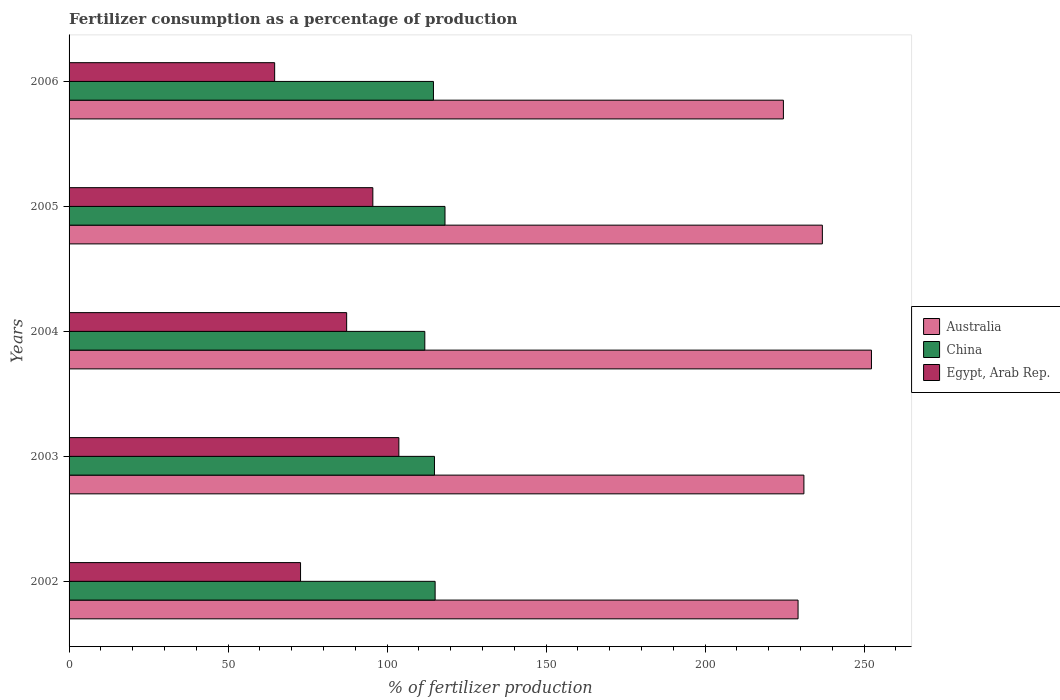Are the number of bars per tick equal to the number of legend labels?
Keep it short and to the point. Yes. What is the label of the 1st group of bars from the top?
Offer a very short reply. 2006. In how many cases, is the number of bars for a given year not equal to the number of legend labels?
Provide a succinct answer. 0. What is the percentage of fertilizers consumed in Egypt, Arab Rep. in 2003?
Make the answer very short. 103.72. Across all years, what is the maximum percentage of fertilizers consumed in Egypt, Arab Rep.?
Keep it short and to the point. 103.72. Across all years, what is the minimum percentage of fertilizers consumed in Australia?
Your answer should be compact. 224.65. In which year was the percentage of fertilizers consumed in Australia maximum?
Provide a short and direct response. 2004. In which year was the percentage of fertilizers consumed in Egypt, Arab Rep. minimum?
Give a very brief answer. 2006. What is the total percentage of fertilizers consumed in China in the graph?
Your response must be concise. 574.74. What is the difference between the percentage of fertilizers consumed in Australia in 2003 and that in 2004?
Keep it short and to the point. -21.24. What is the difference between the percentage of fertilizers consumed in China in 2004 and the percentage of fertilizers consumed in Egypt, Arab Rep. in 2002?
Offer a terse response. 39.09. What is the average percentage of fertilizers consumed in Egypt, Arab Rep. per year?
Give a very brief answer. 84.8. In the year 2004, what is the difference between the percentage of fertilizers consumed in China and percentage of fertilizers consumed in Australia?
Ensure brevity in your answer.  -140.46. In how many years, is the percentage of fertilizers consumed in Australia greater than 90 %?
Offer a very short reply. 5. What is the ratio of the percentage of fertilizers consumed in Egypt, Arab Rep. in 2003 to that in 2006?
Offer a very short reply. 1.6. Is the percentage of fertilizers consumed in Australia in 2002 less than that in 2005?
Offer a terse response. Yes. What is the difference between the highest and the second highest percentage of fertilizers consumed in Australia?
Provide a short and direct response. 15.44. What is the difference between the highest and the lowest percentage of fertilizers consumed in Egypt, Arab Rep.?
Offer a terse response. 39.07. In how many years, is the percentage of fertilizers consumed in Egypt, Arab Rep. greater than the average percentage of fertilizers consumed in Egypt, Arab Rep. taken over all years?
Your answer should be very brief. 3. Is the sum of the percentage of fertilizers consumed in Australia in 2002 and 2003 greater than the maximum percentage of fertilizers consumed in Egypt, Arab Rep. across all years?
Offer a very short reply. Yes. Is it the case that in every year, the sum of the percentage of fertilizers consumed in Australia and percentage of fertilizers consumed in China is greater than the percentage of fertilizers consumed in Egypt, Arab Rep.?
Make the answer very short. Yes. How many bars are there?
Provide a short and direct response. 15. Are all the bars in the graph horizontal?
Offer a very short reply. Yes. How many years are there in the graph?
Your answer should be very brief. 5. Does the graph contain any zero values?
Give a very brief answer. No. Does the graph contain grids?
Keep it short and to the point. No. How are the legend labels stacked?
Your answer should be compact. Vertical. What is the title of the graph?
Make the answer very short. Fertilizer consumption as a percentage of production. What is the label or title of the X-axis?
Make the answer very short. % of fertilizer production. What is the label or title of the Y-axis?
Give a very brief answer. Years. What is the % of fertilizer production of Australia in 2002?
Give a very brief answer. 229.27. What is the % of fertilizer production in China in 2002?
Keep it short and to the point. 115.12. What is the % of fertilizer production in Egypt, Arab Rep. in 2002?
Give a very brief answer. 72.8. What is the % of fertilizer production in Australia in 2003?
Your answer should be very brief. 231.1. What is the % of fertilizer production in China in 2003?
Offer a very short reply. 114.92. What is the % of fertilizer production of Egypt, Arab Rep. in 2003?
Provide a short and direct response. 103.72. What is the % of fertilizer production of Australia in 2004?
Provide a succinct answer. 252.35. What is the % of fertilizer production in China in 2004?
Provide a short and direct response. 111.88. What is the % of fertilizer production in Egypt, Arab Rep. in 2004?
Make the answer very short. 87.3. What is the % of fertilizer production of Australia in 2005?
Offer a very short reply. 236.9. What is the % of fertilizer production of China in 2005?
Keep it short and to the point. 118.23. What is the % of fertilizer production of Egypt, Arab Rep. in 2005?
Your answer should be very brief. 95.53. What is the % of fertilizer production of Australia in 2006?
Offer a very short reply. 224.65. What is the % of fertilizer production in China in 2006?
Keep it short and to the point. 114.6. What is the % of fertilizer production of Egypt, Arab Rep. in 2006?
Your response must be concise. 64.65. Across all years, what is the maximum % of fertilizer production of Australia?
Offer a terse response. 252.35. Across all years, what is the maximum % of fertilizer production of China?
Your response must be concise. 118.23. Across all years, what is the maximum % of fertilizer production of Egypt, Arab Rep.?
Ensure brevity in your answer.  103.72. Across all years, what is the minimum % of fertilizer production of Australia?
Keep it short and to the point. 224.65. Across all years, what is the minimum % of fertilizer production in China?
Provide a short and direct response. 111.88. Across all years, what is the minimum % of fertilizer production of Egypt, Arab Rep.?
Your response must be concise. 64.65. What is the total % of fertilizer production in Australia in the graph?
Your response must be concise. 1174.27. What is the total % of fertilizer production in China in the graph?
Keep it short and to the point. 574.74. What is the total % of fertilizer production of Egypt, Arab Rep. in the graph?
Make the answer very short. 424. What is the difference between the % of fertilizer production of Australia in 2002 and that in 2003?
Make the answer very short. -1.84. What is the difference between the % of fertilizer production of China in 2002 and that in 2003?
Keep it short and to the point. 0.21. What is the difference between the % of fertilizer production in Egypt, Arab Rep. in 2002 and that in 2003?
Ensure brevity in your answer.  -30.92. What is the difference between the % of fertilizer production of Australia in 2002 and that in 2004?
Your answer should be very brief. -23.08. What is the difference between the % of fertilizer production in China in 2002 and that in 2004?
Your response must be concise. 3.24. What is the difference between the % of fertilizer production in Egypt, Arab Rep. in 2002 and that in 2004?
Give a very brief answer. -14.5. What is the difference between the % of fertilizer production of Australia in 2002 and that in 2005?
Offer a very short reply. -7.64. What is the difference between the % of fertilizer production in China in 2002 and that in 2005?
Your response must be concise. -3.1. What is the difference between the % of fertilizer production in Egypt, Arab Rep. in 2002 and that in 2005?
Your answer should be compact. -22.74. What is the difference between the % of fertilizer production of Australia in 2002 and that in 2006?
Provide a succinct answer. 4.61. What is the difference between the % of fertilizer production in China in 2002 and that in 2006?
Offer a terse response. 0.53. What is the difference between the % of fertilizer production of Egypt, Arab Rep. in 2002 and that in 2006?
Your response must be concise. 8.14. What is the difference between the % of fertilizer production in Australia in 2003 and that in 2004?
Offer a terse response. -21.24. What is the difference between the % of fertilizer production of China in 2003 and that in 2004?
Offer a terse response. 3.03. What is the difference between the % of fertilizer production of Egypt, Arab Rep. in 2003 and that in 2004?
Make the answer very short. 16.42. What is the difference between the % of fertilizer production of Australia in 2003 and that in 2005?
Your answer should be very brief. -5.8. What is the difference between the % of fertilizer production in China in 2003 and that in 2005?
Make the answer very short. -3.31. What is the difference between the % of fertilizer production in Egypt, Arab Rep. in 2003 and that in 2005?
Provide a short and direct response. 8.18. What is the difference between the % of fertilizer production in Australia in 2003 and that in 2006?
Provide a succinct answer. 6.45. What is the difference between the % of fertilizer production of China in 2003 and that in 2006?
Provide a succinct answer. 0.32. What is the difference between the % of fertilizer production of Egypt, Arab Rep. in 2003 and that in 2006?
Offer a very short reply. 39.07. What is the difference between the % of fertilizer production in Australia in 2004 and that in 2005?
Offer a terse response. 15.44. What is the difference between the % of fertilizer production of China in 2004 and that in 2005?
Your answer should be very brief. -6.35. What is the difference between the % of fertilizer production of Egypt, Arab Rep. in 2004 and that in 2005?
Offer a terse response. -8.24. What is the difference between the % of fertilizer production in Australia in 2004 and that in 2006?
Your answer should be very brief. 27.69. What is the difference between the % of fertilizer production in China in 2004 and that in 2006?
Your answer should be very brief. -2.71. What is the difference between the % of fertilizer production of Egypt, Arab Rep. in 2004 and that in 2006?
Provide a short and direct response. 22.65. What is the difference between the % of fertilizer production in Australia in 2005 and that in 2006?
Give a very brief answer. 12.25. What is the difference between the % of fertilizer production of China in 2005 and that in 2006?
Give a very brief answer. 3.63. What is the difference between the % of fertilizer production in Egypt, Arab Rep. in 2005 and that in 2006?
Provide a short and direct response. 30.88. What is the difference between the % of fertilizer production in Australia in 2002 and the % of fertilizer production in China in 2003?
Keep it short and to the point. 114.35. What is the difference between the % of fertilizer production of Australia in 2002 and the % of fertilizer production of Egypt, Arab Rep. in 2003?
Your answer should be very brief. 125.55. What is the difference between the % of fertilizer production of China in 2002 and the % of fertilizer production of Egypt, Arab Rep. in 2003?
Make the answer very short. 11.4. What is the difference between the % of fertilizer production of Australia in 2002 and the % of fertilizer production of China in 2004?
Offer a terse response. 117.38. What is the difference between the % of fertilizer production of Australia in 2002 and the % of fertilizer production of Egypt, Arab Rep. in 2004?
Your answer should be very brief. 141.97. What is the difference between the % of fertilizer production in China in 2002 and the % of fertilizer production in Egypt, Arab Rep. in 2004?
Make the answer very short. 27.82. What is the difference between the % of fertilizer production of Australia in 2002 and the % of fertilizer production of China in 2005?
Provide a succinct answer. 111.04. What is the difference between the % of fertilizer production in Australia in 2002 and the % of fertilizer production in Egypt, Arab Rep. in 2005?
Give a very brief answer. 133.73. What is the difference between the % of fertilizer production of China in 2002 and the % of fertilizer production of Egypt, Arab Rep. in 2005?
Provide a short and direct response. 19.59. What is the difference between the % of fertilizer production in Australia in 2002 and the % of fertilizer production in China in 2006?
Make the answer very short. 114.67. What is the difference between the % of fertilizer production in Australia in 2002 and the % of fertilizer production in Egypt, Arab Rep. in 2006?
Your answer should be very brief. 164.61. What is the difference between the % of fertilizer production in China in 2002 and the % of fertilizer production in Egypt, Arab Rep. in 2006?
Give a very brief answer. 50.47. What is the difference between the % of fertilizer production in Australia in 2003 and the % of fertilizer production in China in 2004?
Your response must be concise. 119.22. What is the difference between the % of fertilizer production in Australia in 2003 and the % of fertilizer production in Egypt, Arab Rep. in 2004?
Make the answer very short. 143.8. What is the difference between the % of fertilizer production of China in 2003 and the % of fertilizer production of Egypt, Arab Rep. in 2004?
Keep it short and to the point. 27.62. What is the difference between the % of fertilizer production of Australia in 2003 and the % of fertilizer production of China in 2005?
Make the answer very short. 112.88. What is the difference between the % of fertilizer production of Australia in 2003 and the % of fertilizer production of Egypt, Arab Rep. in 2005?
Provide a short and direct response. 135.57. What is the difference between the % of fertilizer production in China in 2003 and the % of fertilizer production in Egypt, Arab Rep. in 2005?
Your answer should be compact. 19.38. What is the difference between the % of fertilizer production of Australia in 2003 and the % of fertilizer production of China in 2006?
Ensure brevity in your answer.  116.51. What is the difference between the % of fertilizer production of Australia in 2003 and the % of fertilizer production of Egypt, Arab Rep. in 2006?
Your response must be concise. 166.45. What is the difference between the % of fertilizer production in China in 2003 and the % of fertilizer production in Egypt, Arab Rep. in 2006?
Ensure brevity in your answer.  50.26. What is the difference between the % of fertilizer production of Australia in 2004 and the % of fertilizer production of China in 2005?
Keep it short and to the point. 134.12. What is the difference between the % of fertilizer production in Australia in 2004 and the % of fertilizer production in Egypt, Arab Rep. in 2005?
Keep it short and to the point. 156.81. What is the difference between the % of fertilizer production in China in 2004 and the % of fertilizer production in Egypt, Arab Rep. in 2005?
Your response must be concise. 16.35. What is the difference between the % of fertilizer production of Australia in 2004 and the % of fertilizer production of China in 2006?
Your answer should be very brief. 137.75. What is the difference between the % of fertilizer production of Australia in 2004 and the % of fertilizer production of Egypt, Arab Rep. in 2006?
Ensure brevity in your answer.  187.69. What is the difference between the % of fertilizer production of China in 2004 and the % of fertilizer production of Egypt, Arab Rep. in 2006?
Make the answer very short. 47.23. What is the difference between the % of fertilizer production in Australia in 2005 and the % of fertilizer production in China in 2006?
Keep it short and to the point. 122.31. What is the difference between the % of fertilizer production in Australia in 2005 and the % of fertilizer production in Egypt, Arab Rep. in 2006?
Make the answer very short. 172.25. What is the difference between the % of fertilizer production in China in 2005 and the % of fertilizer production in Egypt, Arab Rep. in 2006?
Provide a short and direct response. 53.57. What is the average % of fertilizer production in Australia per year?
Make the answer very short. 234.85. What is the average % of fertilizer production of China per year?
Give a very brief answer. 114.95. What is the average % of fertilizer production of Egypt, Arab Rep. per year?
Keep it short and to the point. 84.8. In the year 2002, what is the difference between the % of fertilizer production in Australia and % of fertilizer production in China?
Make the answer very short. 114.14. In the year 2002, what is the difference between the % of fertilizer production in Australia and % of fertilizer production in Egypt, Arab Rep.?
Ensure brevity in your answer.  156.47. In the year 2002, what is the difference between the % of fertilizer production of China and % of fertilizer production of Egypt, Arab Rep.?
Your answer should be very brief. 42.33. In the year 2003, what is the difference between the % of fertilizer production in Australia and % of fertilizer production in China?
Your response must be concise. 116.19. In the year 2003, what is the difference between the % of fertilizer production in Australia and % of fertilizer production in Egypt, Arab Rep.?
Your answer should be very brief. 127.38. In the year 2003, what is the difference between the % of fertilizer production in China and % of fertilizer production in Egypt, Arab Rep.?
Your answer should be compact. 11.2. In the year 2004, what is the difference between the % of fertilizer production in Australia and % of fertilizer production in China?
Make the answer very short. 140.46. In the year 2004, what is the difference between the % of fertilizer production of Australia and % of fertilizer production of Egypt, Arab Rep.?
Your answer should be very brief. 165.05. In the year 2004, what is the difference between the % of fertilizer production of China and % of fertilizer production of Egypt, Arab Rep.?
Ensure brevity in your answer.  24.58. In the year 2005, what is the difference between the % of fertilizer production of Australia and % of fertilizer production of China?
Offer a very short reply. 118.68. In the year 2005, what is the difference between the % of fertilizer production of Australia and % of fertilizer production of Egypt, Arab Rep.?
Ensure brevity in your answer.  141.37. In the year 2005, what is the difference between the % of fertilizer production in China and % of fertilizer production in Egypt, Arab Rep.?
Give a very brief answer. 22.69. In the year 2006, what is the difference between the % of fertilizer production in Australia and % of fertilizer production in China?
Keep it short and to the point. 110.06. In the year 2006, what is the difference between the % of fertilizer production in Australia and % of fertilizer production in Egypt, Arab Rep.?
Your answer should be compact. 160. In the year 2006, what is the difference between the % of fertilizer production of China and % of fertilizer production of Egypt, Arab Rep.?
Give a very brief answer. 49.94. What is the ratio of the % of fertilizer production of China in 2002 to that in 2003?
Make the answer very short. 1. What is the ratio of the % of fertilizer production in Egypt, Arab Rep. in 2002 to that in 2003?
Provide a short and direct response. 0.7. What is the ratio of the % of fertilizer production of Australia in 2002 to that in 2004?
Give a very brief answer. 0.91. What is the ratio of the % of fertilizer production of Egypt, Arab Rep. in 2002 to that in 2004?
Offer a very short reply. 0.83. What is the ratio of the % of fertilizer production of Australia in 2002 to that in 2005?
Your response must be concise. 0.97. What is the ratio of the % of fertilizer production in China in 2002 to that in 2005?
Your response must be concise. 0.97. What is the ratio of the % of fertilizer production in Egypt, Arab Rep. in 2002 to that in 2005?
Offer a terse response. 0.76. What is the ratio of the % of fertilizer production of Australia in 2002 to that in 2006?
Provide a succinct answer. 1.02. What is the ratio of the % of fertilizer production in Egypt, Arab Rep. in 2002 to that in 2006?
Make the answer very short. 1.13. What is the ratio of the % of fertilizer production in Australia in 2003 to that in 2004?
Keep it short and to the point. 0.92. What is the ratio of the % of fertilizer production in China in 2003 to that in 2004?
Your answer should be compact. 1.03. What is the ratio of the % of fertilizer production of Egypt, Arab Rep. in 2003 to that in 2004?
Keep it short and to the point. 1.19. What is the ratio of the % of fertilizer production in Australia in 2003 to that in 2005?
Your response must be concise. 0.98. What is the ratio of the % of fertilizer production of China in 2003 to that in 2005?
Make the answer very short. 0.97. What is the ratio of the % of fertilizer production of Egypt, Arab Rep. in 2003 to that in 2005?
Offer a terse response. 1.09. What is the ratio of the % of fertilizer production in Australia in 2003 to that in 2006?
Keep it short and to the point. 1.03. What is the ratio of the % of fertilizer production in China in 2003 to that in 2006?
Your answer should be very brief. 1. What is the ratio of the % of fertilizer production in Egypt, Arab Rep. in 2003 to that in 2006?
Offer a very short reply. 1.6. What is the ratio of the % of fertilizer production in Australia in 2004 to that in 2005?
Make the answer very short. 1.07. What is the ratio of the % of fertilizer production in China in 2004 to that in 2005?
Give a very brief answer. 0.95. What is the ratio of the % of fertilizer production in Egypt, Arab Rep. in 2004 to that in 2005?
Make the answer very short. 0.91. What is the ratio of the % of fertilizer production of Australia in 2004 to that in 2006?
Your answer should be very brief. 1.12. What is the ratio of the % of fertilizer production in China in 2004 to that in 2006?
Your response must be concise. 0.98. What is the ratio of the % of fertilizer production of Egypt, Arab Rep. in 2004 to that in 2006?
Your response must be concise. 1.35. What is the ratio of the % of fertilizer production in Australia in 2005 to that in 2006?
Give a very brief answer. 1.05. What is the ratio of the % of fertilizer production in China in 2005 to that in 2006?
Keep it short and to the point. 1.03. What is the ratio of the % of fertilizer production in Egypt, Arab Rep. in 2005 to that in 2006?
Offer a terse response. 1.48. What is the difference between the highest and the second highest % of fertilizer production in Australia?
Your answer should be compact. 15.44. What is the difference between the highest and the second highest % of fertilizer production in China?
Provide a short and direct response. 3.1. What is the difference between the highest and the second highest % of fertilizer production of Egypt, Arab Rep.?
Your response must be concise. 8.18. What is the difference between the highest and the lowest % of fertilizer production in Australia?
Offer a terse response. 27.69. What is the difference between the highest and the lowest % of fertilizer production of China?
Give a very brief answer. 6.35. What is the difference between the highest and the lowest % of fertilizer production in Egypt, Arab Rep.?
Offer a very short reply. 39.07. 